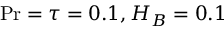Convert formula to latex. <formula><loc_0><loc_0><loc_500><loc_500>P r = \tau = 0 . 1 , H _ { B } = 0 . 1</formula> 